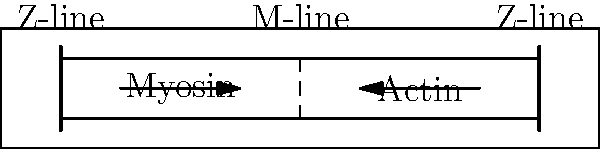In the sarcomere structure shown above, which molecular process is primarily responsible for the sliding filament mechanism during muscle contraction, and how does it affect the overall length of the sarcomere? 1. The sarcomere is the basic functional unit of skeletal muscle fibers.

2. The sliding filament mechanism is the primary process responsible for muscle contraction:
   a. Thick filaments (myosin) and thin filaments (actin) slide past each other.
   b. This is driven by the formation and breaking of cross-bridges between myosin heads and actin.

3. The process is initiated by:
   a. Calcium release from the sarcoplasmic reticulum.
   b. Calcium binding to troponin, causing a conformational change in tropomyosin.
   c. This exposes the myosin-binding sites on actin.

4. The power stroke:
   a. Myosin heads attach to actin, forming cross-bridges.
   b. ATP hydrolysis causes a conformational change in myosin.
   c. This pulls the actin filaments towards the center of the sarcomere.

5. Effect on sarcomere length:
   a. The Z-lines (ends of the sarcomere) are pulled inward.
   b. The overall length of the sarcomere decreases.
   c. The I-bands (regions containing only actin) shorten.
   d. The H-zone (region of myosin not overlapping with actin) narrows or disappears.
   e. The A-band (region of myosin) maintains a constant length.

6. The cycle repeats as long as calcium levels remain elevated and ATP is available.

7. Relaxation occurs when:
   a. Calcium is actively pumped back into the sarcoplasmic reticulum.
   b. Myosin detaches from actin.
   c. The sarcomere returns to its resting length.
Answer: Cross-bridge cycling between myosin and actin; sarcomere length decreases. 